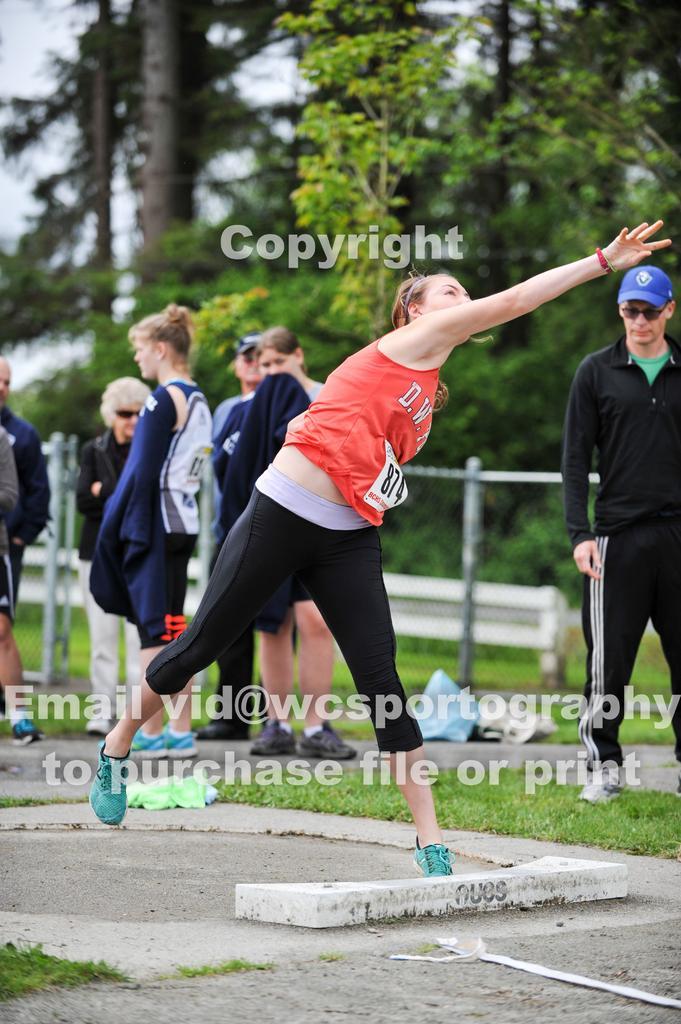Can you describe this image briefly? In the picture I can see people standing on the ground. I can also see the grass. In the background I can see trees and the sky. Here I can see watermarks on the image. 